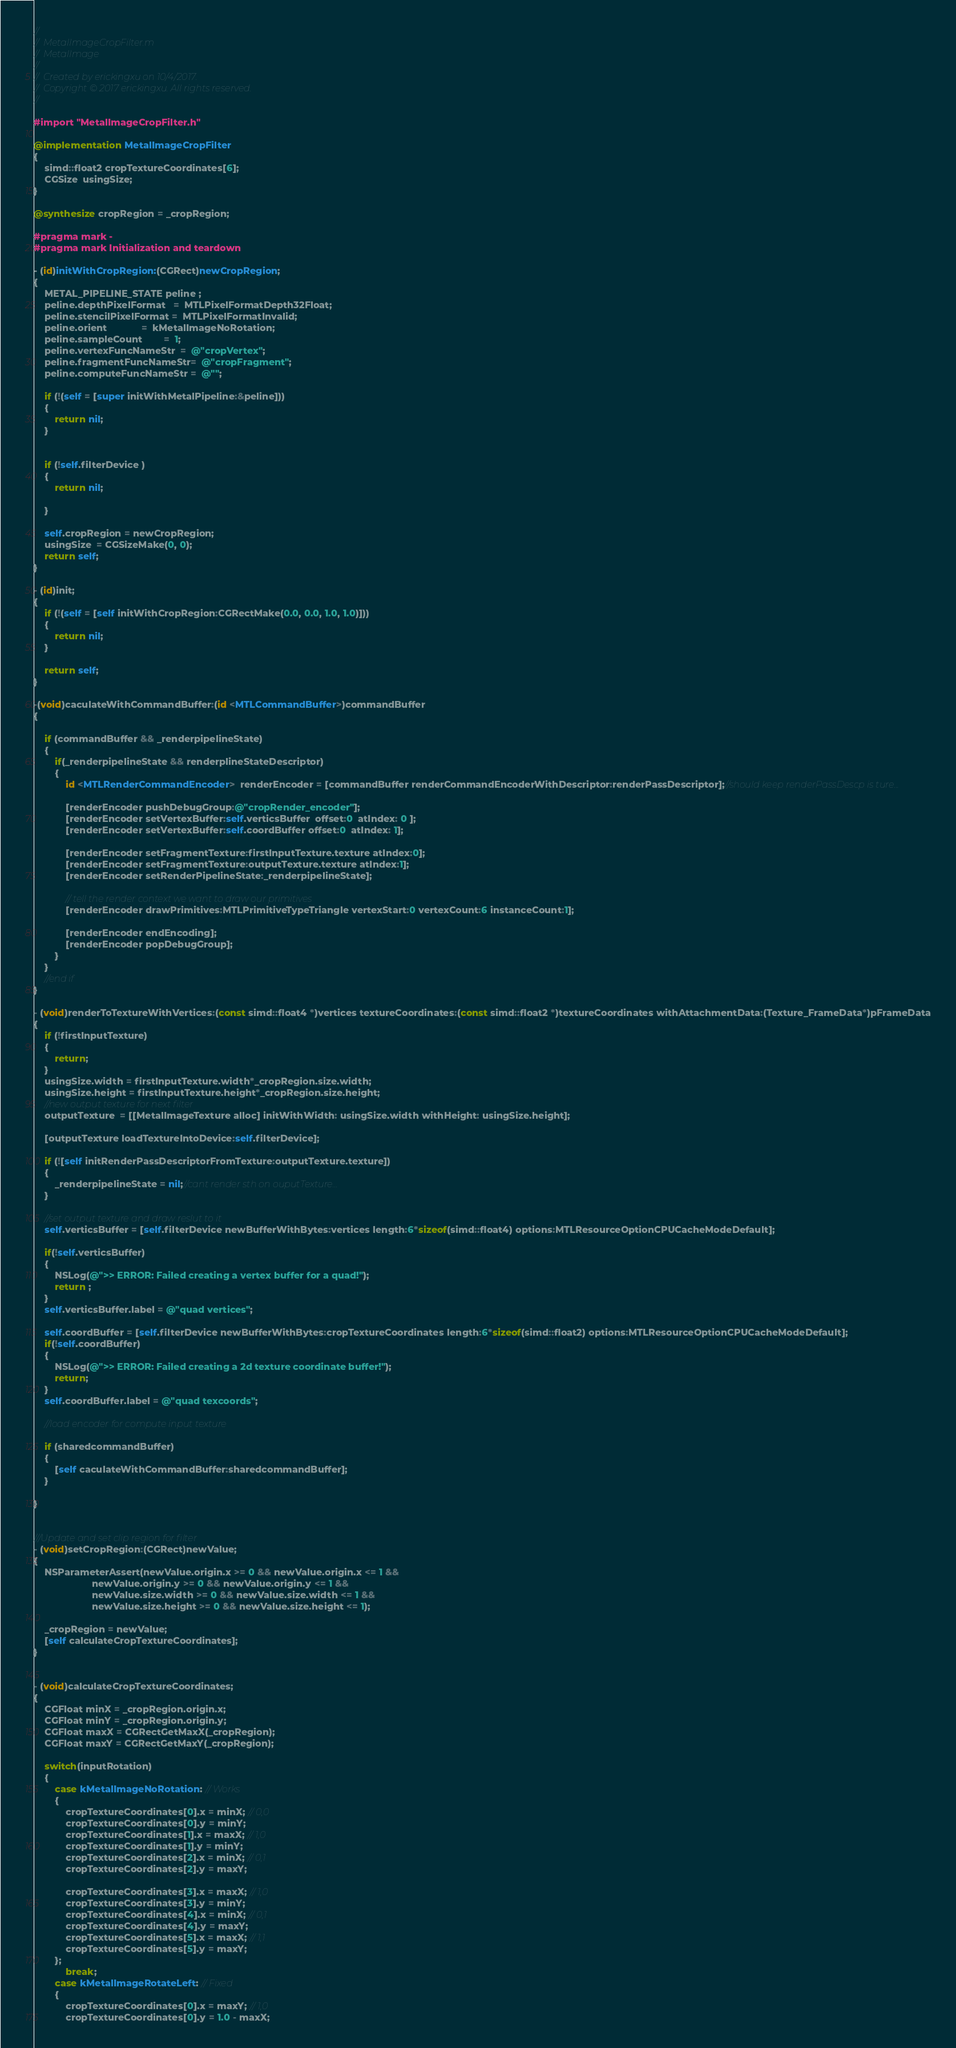Convert code to text. <code><loc_0><loc_0><loc_500><loc_500><_ObjectiveC_>//
//  MetalImageCropFilter.m
//  MetalImage
//
//  Created by erickingxu on 10/4/2017.
//  Copyright © 2017 erickingxu. All rights reserved.
//

#import "MetalImageCropFilter.h"

@implementation MetalImageCropFilter
{
    simd::float2 cropTextureCoordinates[6];
    CGSize  usingSize;
}

@synthesize cropRegion = _cropRegion;

#pragma mark -
#pragma mark Initialization and teardown

- (id)initWithCropRegion:(CGRect)newCropRegion;
{
    METAL_PIPELINE_STATE peline ;
    peline.depthPixelFormat   =  MTLPixelFormatDepth32Float;
    peline.stencilPixelFormat =  MTLPixelFormatInvalid;
    peline.orient             =  kMetalImageNoRotation;
    peline.sampleCount        =  1;
    peline.vertexFuncNameStr  =  @"cropVertex";
    peline.fragmentFuncNameStr=  @"cropFragment";
    peline.computeFuncNameStr =  @"";
    
    if (!(self = [super initWithMetalPipeline:&peline]))
    {
        return nil;
    }
    
    
    if (!self.filterDevice )
    {
        return nil;
        
    }
    
    self.cropRegion = newCropRegion;
    usingSize  = CGSizeMake(0, 0);
    return self;
}

- (id)init;
{
    if (!(self = [self initWithCropRegion:CGRectMake(0.0, 0.0, 1.0, 1.0)]))
    {
        return nil;
    }
    
    return self;
}

-(void)caculateWithCommandBuffer:(id <MTLCommandBuffer>)commandBuffer
{
    
    if (commandBuffer && _renderpipelineState)
    {
        if(_renderpipelineState && renderplineStateDescriptor)
        {
            id <MTLRenderCommandEncoder>  renderEncoder = [commandBuffer renderCommandEncoderWithDescriptor:renderPassDescriptor];//should keep renderPassDescp is ture...
            
            [renderEncoder pushDebugGroup:@"cropRender_encoder"];
            [renderEncoder setVertexBuffer:self.verticsBuffer  offset:0  atIndex: 0 ];
            [renderEncoder setVertexBuffer:self.coordBuffer offset:0  atIndex: 1];
            
            [renderEncoder setFragmentTexture:firstInputTexture.texture atIndex:0];
            [renderEncoder setFragmentTexture:outputTexture.texture atIndex:1];
            [renderEncoder setRenderPipelineState:_renderpipelineState];
            
            // tell the render context we want to draw our primitives
            [renderEncoder drawPrimitives:MTLPrimitiveTypeTriangle vertexStart:0 vertexCount:6 instanceCount:1];
            
            [renderEncoder endEncoding];
            [renderEncoder popDebugGroup];
        }
    }
    //end if
}

- (void)renderToTextureWithVertices:(const simd::float4 *)vertices textureCoordinates:(const simd::float2 *)textureCoordinates withAttachmentData:(Texture_FrameData*)pFrameData
{
    if (!firstInputTexture)
    {
        return;
    }
    usingSize.width = firstInputTexture.width*_cropRegion.size.width;
    usingSize.height = firstInputTexture.height*_cropRegion.size.height;
    //new output texture for next filter
    outputTexture  = [[MetalImageTexture alloc] initWithWidth: usingSize.width withHeight: usingSize.height];
    
    [outputTexture loadTextureIntoDevice:self.filterDevice];
    
    if (![self initRenderPassDescriptorFromTexture:outputTexture.texture])
    {
        _renderpipelineState = nil;//cant render sth on ouputTexture...
    }
    
    //set output texture and draw reslut to it
    self.verticsBuffer = [self.filterDevice newBufferWithBytes:vertices length:6*sizeof(simd::float4) options:MTLResourceOptionCPUCacheModeDefault];
    
    if(!self.verticsBuffer)
    {
        NSLog(@">> ERROR: Failed creating a vertex buffer for a quad!");
        return ;
    }
    self.verticsBuffer.label = @"quad vertices";
    
    self.coordBuffer = [self.filterDevice newBufferWithBytes:cropTextureCoordinates length:6*sizeof(simd::float2) options:MTLResourceOptionCPUCacheModeDefault];
    if(!self.coordBuffer)
    {
        NSLog(@">> ERROR: Failed creating a 2d texture coordinate buffer!");
        return;
    }
    self.coordBuffer.label = @"quad texcoords";
    
    //load encoder for compute input texture
    
    if (sharedcommandBuffer)
    {
        [self caculateWithCommandBuffer:sharedcommandBuffer];
    }
    
}


///Update and set clip region for filter
- (void)setCropRegion:(CGRect)newValue;
{
    NSParameterAssert(newValue.origin.x >= 0 && newValue.origin.x <= 1 &&
                      newValue.origin.y >= 0 && newValue.origin.y <= 1 &&
                      newValue.size.width >= 0 && newValue.size.width <= 1 &&
                      newValue.size.height >= 0 && newValue.size.height <= 1);
    
    _cropRegion = newValue;
    [self calculateCropTextureCoordinates];
}


- (void)calculateCropTextureCoordinates;
{
    CGFloat minX = _cropRegion.origin.x;
    CGFloat minY = _cropRegion.origin.y;
    CGFloat maxX = CGRectGetMaxX(_cropRegion);
    CGFloat maxY = CGRectGetMaxY(_cropRegion);
    
    switch(inputRotation)
    {
        case kMetalImageNoRotation: // Works
        {
            cropTextureCoordinates[0].x = minX; // 0,0
            cropTextureCoordinates[0].y = minY;
            cropTextureCoordinates[1].x = maxX; // 1,0
            cropTextureCoordinates[1].y = minY;
            cropTextureCoordinates[2].x = minX; // 0,1
            cropTextureCoordinates[2].y = maxY;
            
            cropTextureCoordinates[3].x = maxX; // 1,0
            cropTextureCoordinates[3].y = minY;
            cropTextureCoordinates[4].x = minX; // 0,1
            cropTextureCoordinates[4].y = maxY;
            cropTextureCoordinates[5].x = maxX; // 1,1
            cropTextureCoordinates[5].y = maxY;
        };
            break;
        case kMetalImageRotateLeft: // Fixed
        {
            cropTextureCoordinates[0].x = maxY; // 1,0
            cropTextureCoordinates[0].y = 1.0 - maxX;</code> 